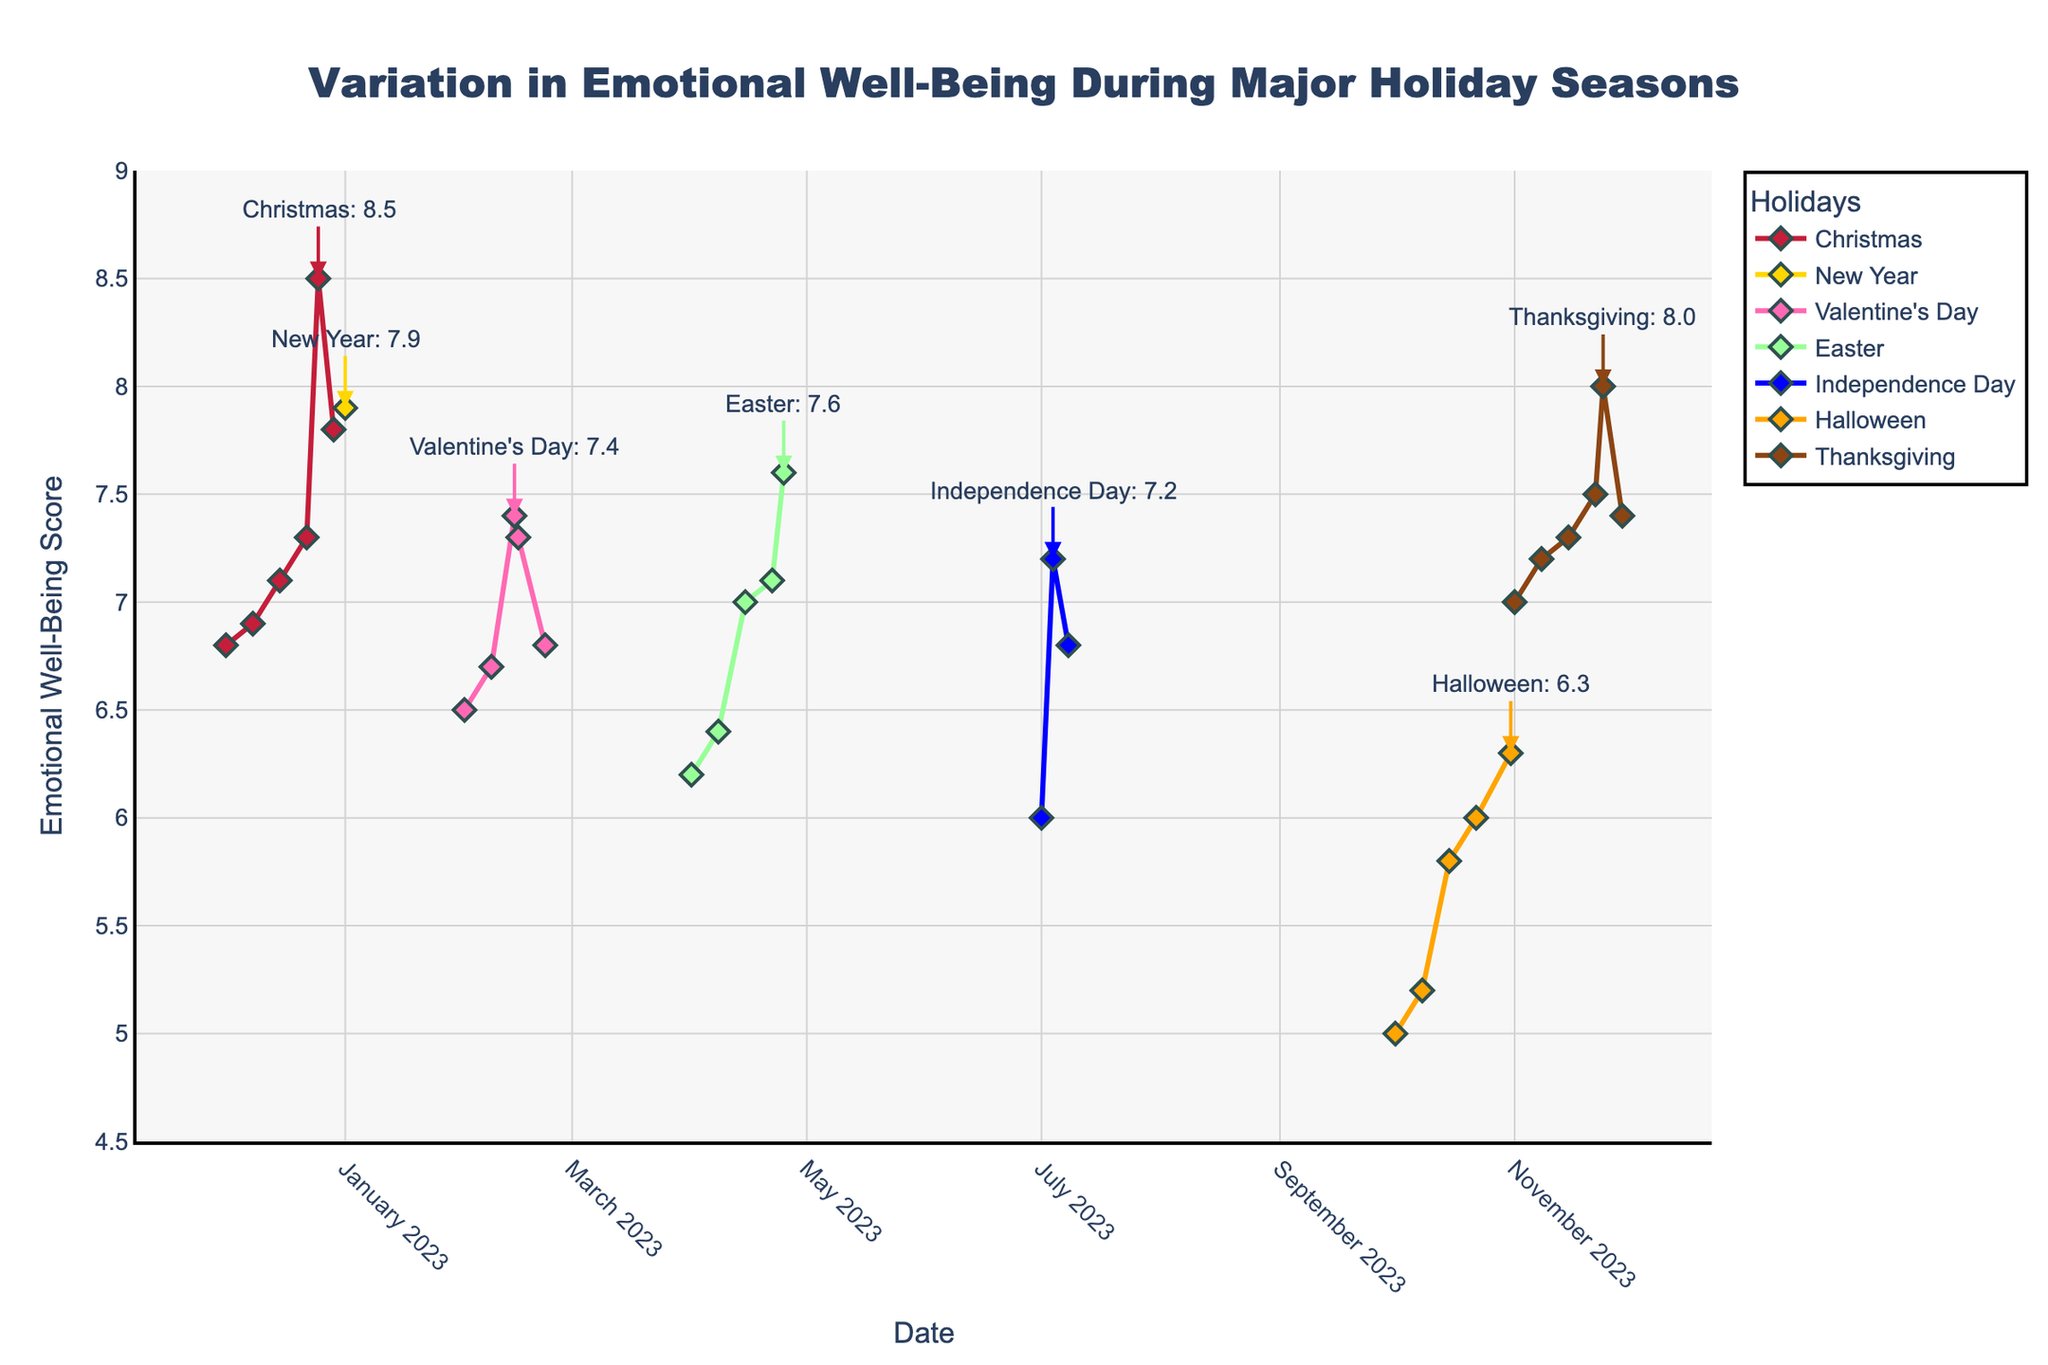What is the title of the figure? The title of the figure is located at the top and should be one of the most prominent texts.
Answer: Variation in Emotional Well-Being During Major Holiday Seasons Which holiday shows the highest peak in emotional well-being? The figure shows annotations indicating the peak values for each holiday. By comparing these annotations, we can identify the highest peak.
Answer: Christmas How does emotional well-being during Thanksgiving compare to Halloween? By examining the lines and markers for both Thanksgiving and Halloween, we can see that Thanksgiving shows consistently higher emotional well-being scores.
Answer: Thanksgiving is higher What is the trend in emotional well-being in the week leading up to Easter? Look at the data points corresponding to Easter and observe the week leading up to it. The scores show an upward trend.
Answer: Increasing What's the difference in emotional well-being score between Christmas and Valentine's Day on their peak days? Identify the peak values for both holidays from their respective annotations and subtract the Valentine's Day peak from the Christmas peak. The peak value for Christmas is 8.5 and for Valentine's Day is 7.4. So, 8.5 - 7.4 = 1.1
Answer: 1.1 During which holiday season does emotional well-being drop the most after reaching its peak? Observe the annotated points for each holiday season, and compare the decrease in scores right after the peaks. The largest drop is observed for Thanksgiving, dropping from 8.0 to 7.4.
Answer: Thanksgiving Which holidays have a peak emotional well-being score over 7.5? Identify the peak annotations for each holiday and check if the value is greater than 7.5. Christmas (8.5), New Year (7.9), and Thanksgiving (8.0) all have peaks over 7.5.
Answer: Christmas, New Year, Thanksgiving What's the average emotional well-being score in the month of December? The figure shows the dates and corresponding scores for December. Sum up these values and divide by the number of data points. The scores are 6.8, 6.9, 7.1, 7.3, 8.5, and 7.8. Calculate (6.8+6.9+7.1+7.3+8.5+7.8) / 6 = 7.4
Answer: 7.4 Which holiday has the lowest emotional well-being score, and what is that score? By examining the plotted lines, find the lowest point across all holidays. Halloween has the lowest score at 5.0.
Answer: Halloween, 5.0 